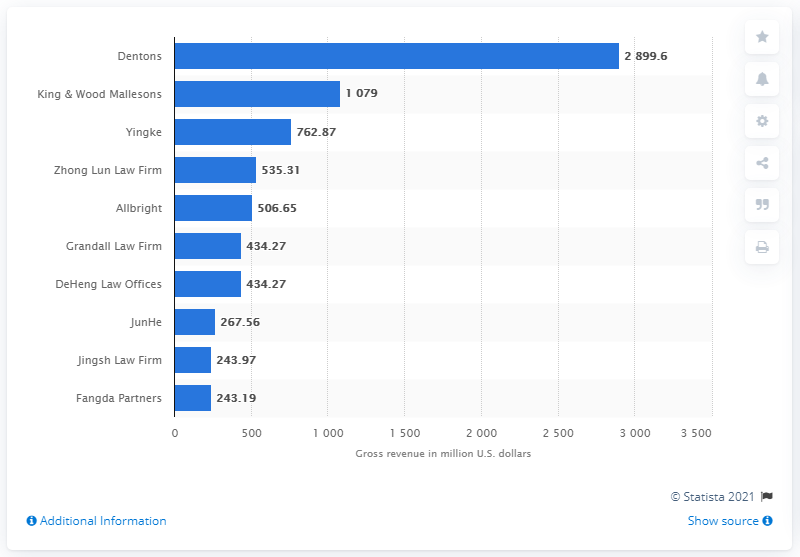Identify some key points in this picture. In 2019, the gross revenue of Dentons was $2899.6 million. Dentons is the highest-grossing law firm in China. 